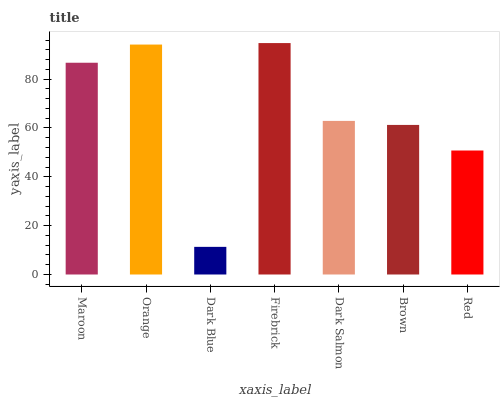Is Dark Blue the minimum?
Answer yes or no. Yes. Is Firebrick the maximum?
Answer yes or no. Yes. Is Orange the minimum?
Answer yes or no. No. Is Orange the maximum?
Answer yes or no. No. Is Orange greater than Maroon?
Answer yes or no. Yes. Is Maroon less than Orange?
Answer yes or no. Yes. Is Maroon greater than Orange?
Answer yes or no. No. Is Orange less than Maroon?
Answer yes or no. No. Is Dark Salmon the high median?
Answer yes or no. Yes. Is Dark Salmon the low median?
Answer yes or no. Yes. Is Dark Blue the high median?
Answer yes or no. No. Is Firebrick the low median?
Answer yes or no. No. 